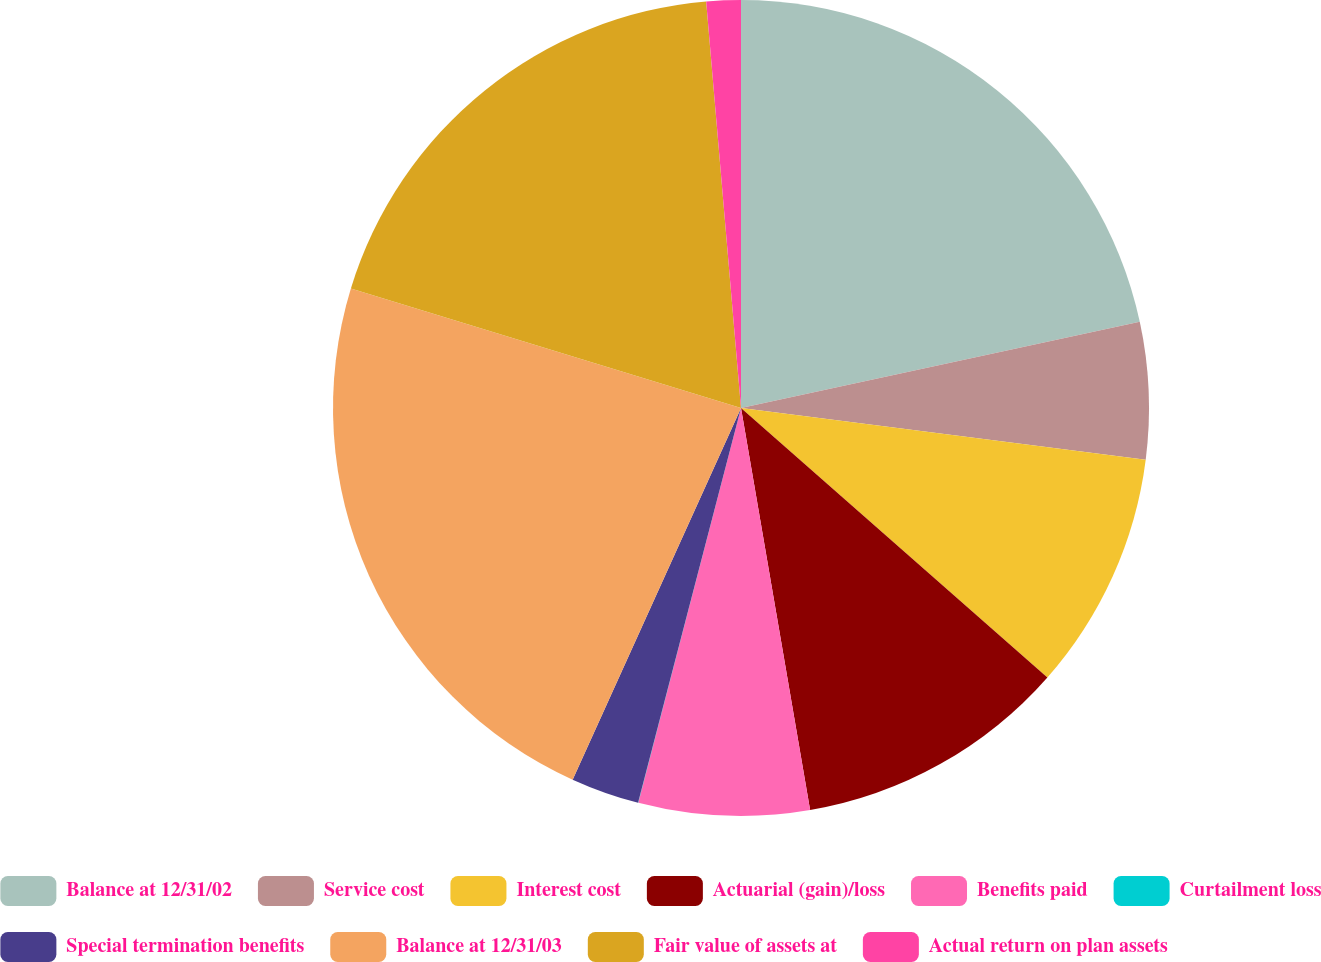Convert chart. <chart><loc_0><loc_0><loc_500><loc_500><pie_chart><fcel>Balance at 12/31/02<fcel>Service cost<fcel>Interest cost<fcel>Actuarial (gain)/loss<fcel>Benefits paid<fcel>Curtailment loss<fcel>Special termination benefits<fcel>Balance at 12/31/03<fcel>Fair value of assets at<fcel>Actual return on plan assets<nl><fcel>21.61%<fcel>5.41%<fcel>9.46%<fcel>10.81%<fcel>6.76%<fcel>0.01%<fcel>2.71%<fcel>22.96%<fcel>18.91%<fcel>1.36%<nl></chart> 